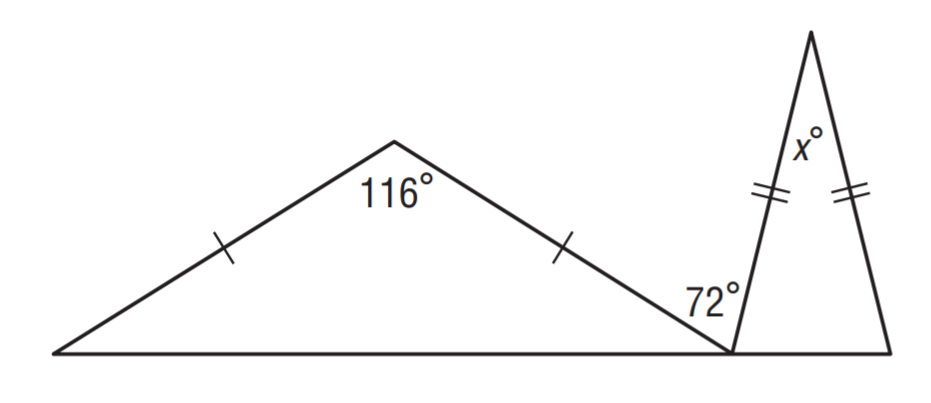Answer the mathemtical geometry problem and directly provide the correct option letter.
Question: Find x.
Choices: A: 22 B: 28 C: 32 D: 36 B 